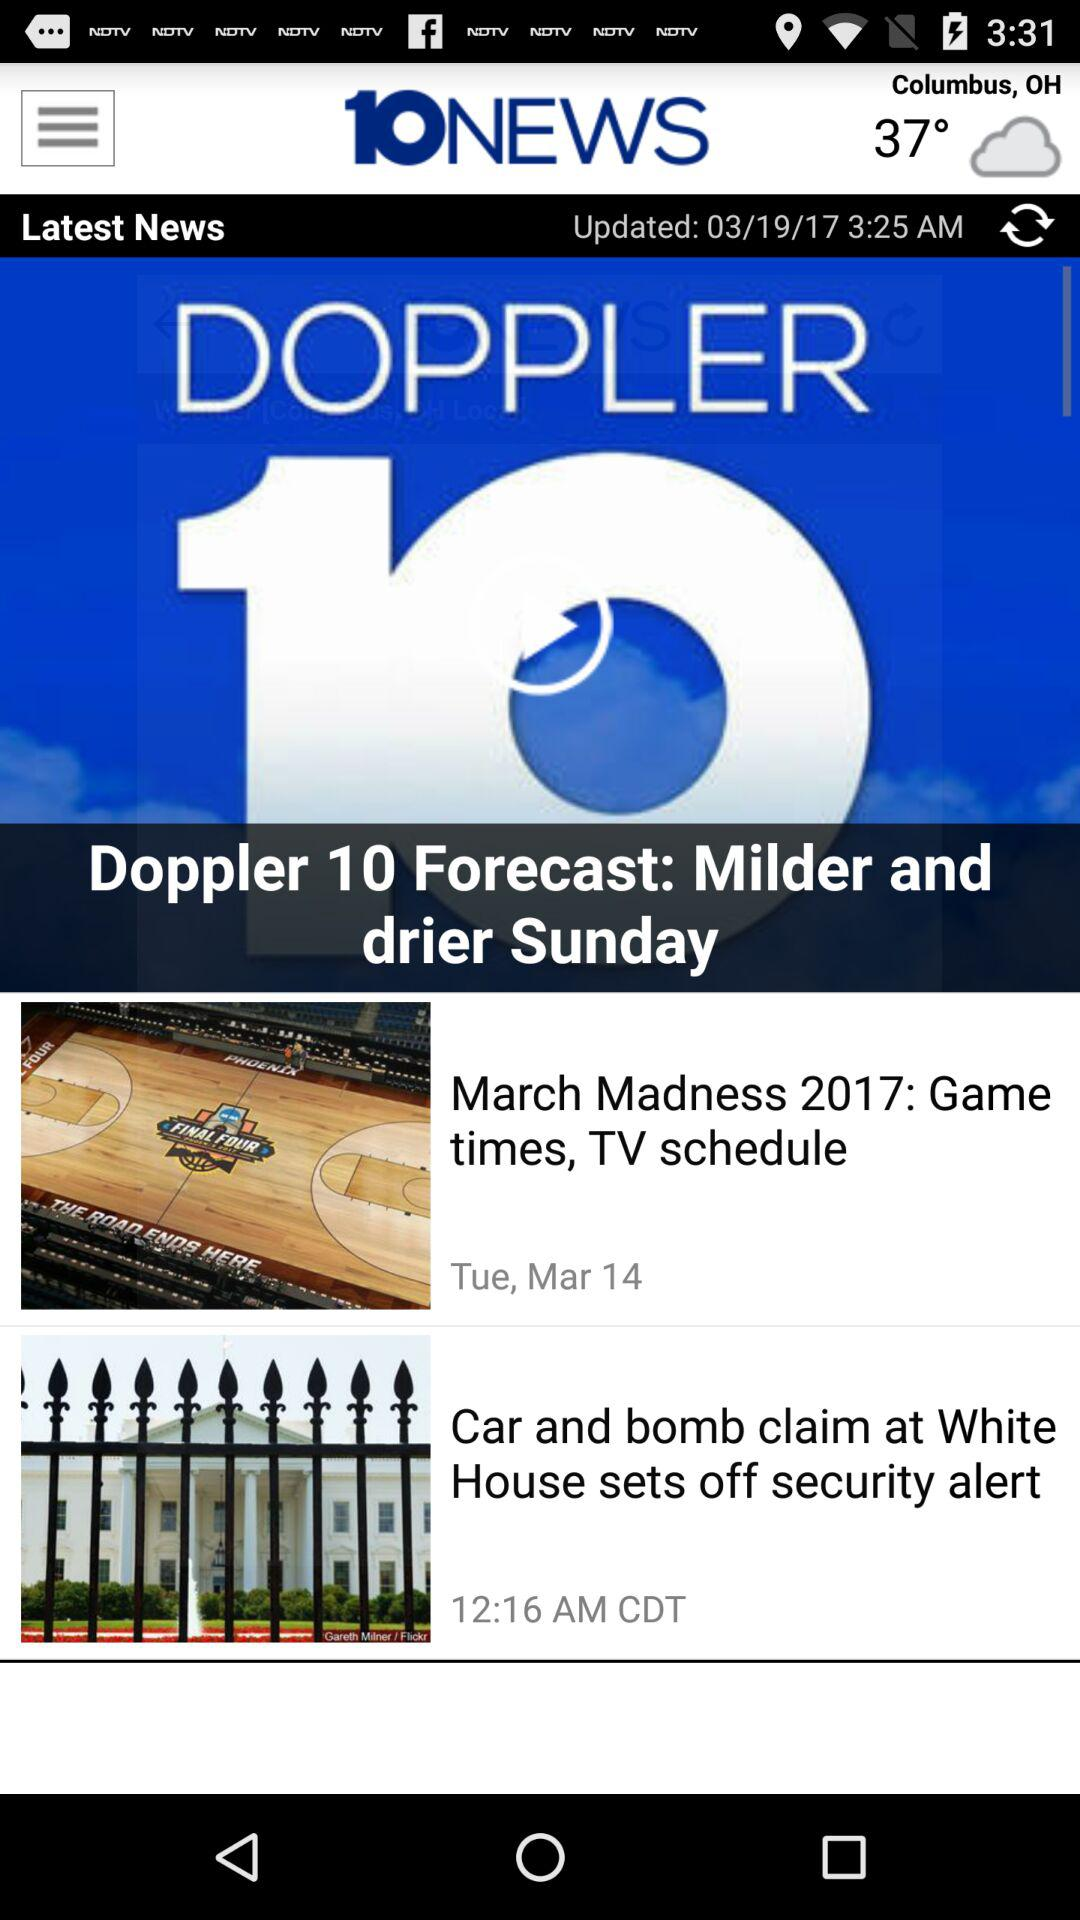What is the name of the news channel? The name of the news channel is "10NEWS". 